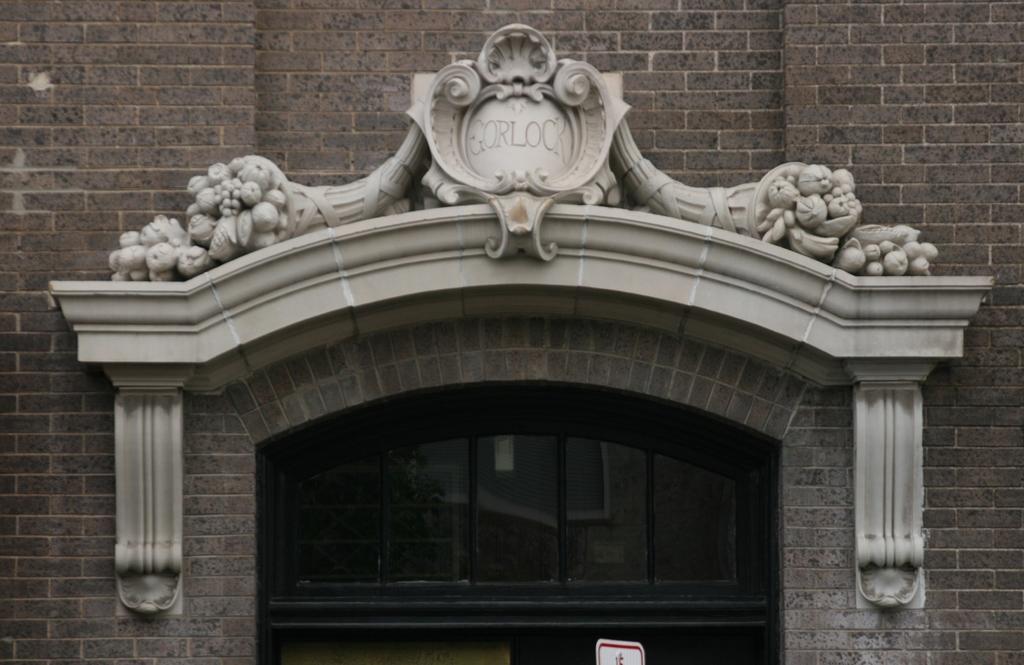Can you describe this image briefly? In this image I can see an arch and the glass door and the building is in brown color. 